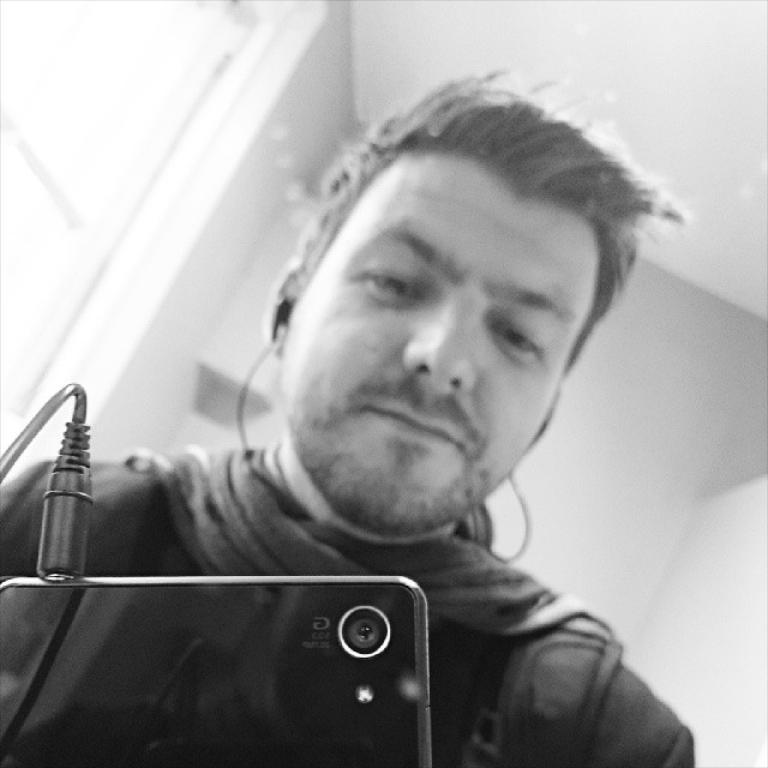What is the color scheme of the image? The image is black and white. What can be seen hanging in the image? There is a mobile in the image. What is connected to the mobile? There is a cable in the image. Who is observing the mobile? A person is looking at the mobile. What type of structures can be seen in the background of the image? There are walls in the background of the image. Is there any natural element visible in the background? Yes, there is a window in the background of the image. How many rabbits can be seen hopping on the ground in the image? There are no rabbits or ground visible in the image; it is a black and white image featuring a mobile, a cable, and a person looking at the mobile. 